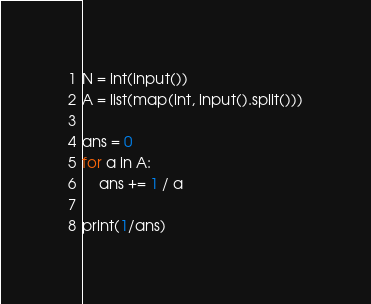Convert code to text. <code><loc_0><loc_0><loc_500><loc_500><_Python_>N = int(input())
A = list(map(int, input().split()))

ans = 0
for a in A:
    ans += 1 / a

print(1/ans)</code> 